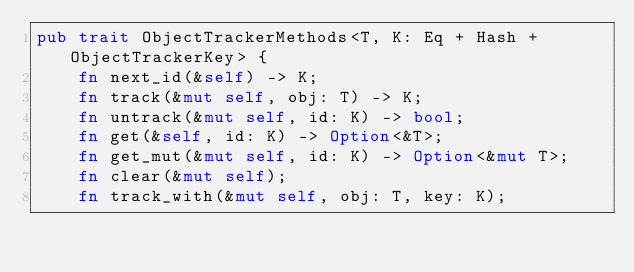<code> <loc_0><loc_0><loc_500><loc_500><_Rust_>pub trait ObjectTrackerMethods<T, K: Eq + Hash + ObjectTrackerKey> {
    fn next_id(&self) -> K;
    fn track(&mut self, obj: T) -> K;
    fn untrack(&mut self, id: K) -> bool;
    fn get(&self, id: K) -> Option<&T>;
    fn get_mut(&mut self, id: K) -> Option<&mut T>;
    fn clear(&mut self);
    fn track_with(&mut self, obj: T, key: K);</code> 